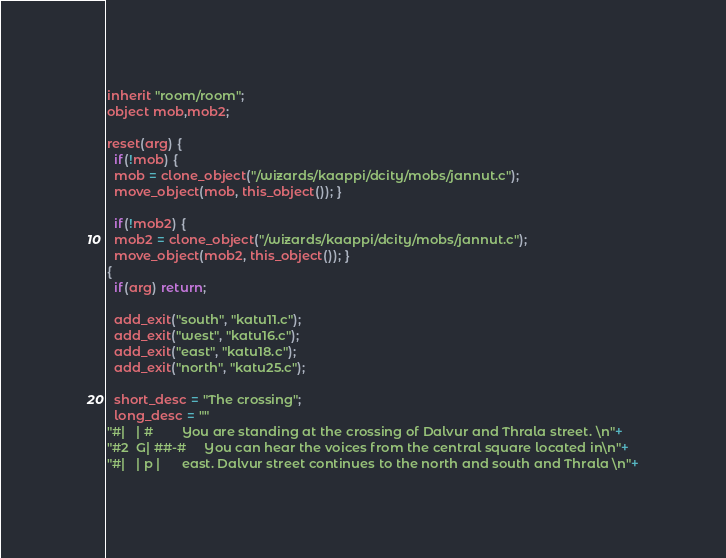Convert code to text. <code><loc_0><loc_0><loc_500><loc_500><_C_>inherit "room/room";
object mob,mob2;

reset(arg) {
  if(!mob) {
  mob = clone_object("/wizards/kaappi/dcity/mobs/jannut.c");
  move_object(mob, this_object()); }

  if(!mob2) {
  mob2 = clone_object("/wizards/kaappi/dcity/mobs/jannut.c");
  move_object(mob2, this_object()); }
{
  if(arg) return;

  add_exit("south", "katu11.c");
  add_exit("west", "katu16.c");
  add_exit("east", "katu18.c");
  add_exit("north", "katu25.c");
  
  short_desc = "The crossing";
  long_desc = ""
"#|   | #        You are standing at the crossing of Dalvur and Thrala street. \n"+
"#2  G| ##-#     You can hear the voices from the central square located in\n"+
"#|   | p |      east. Dalvur street continues to the north and south and Thrala \n"+</code> 